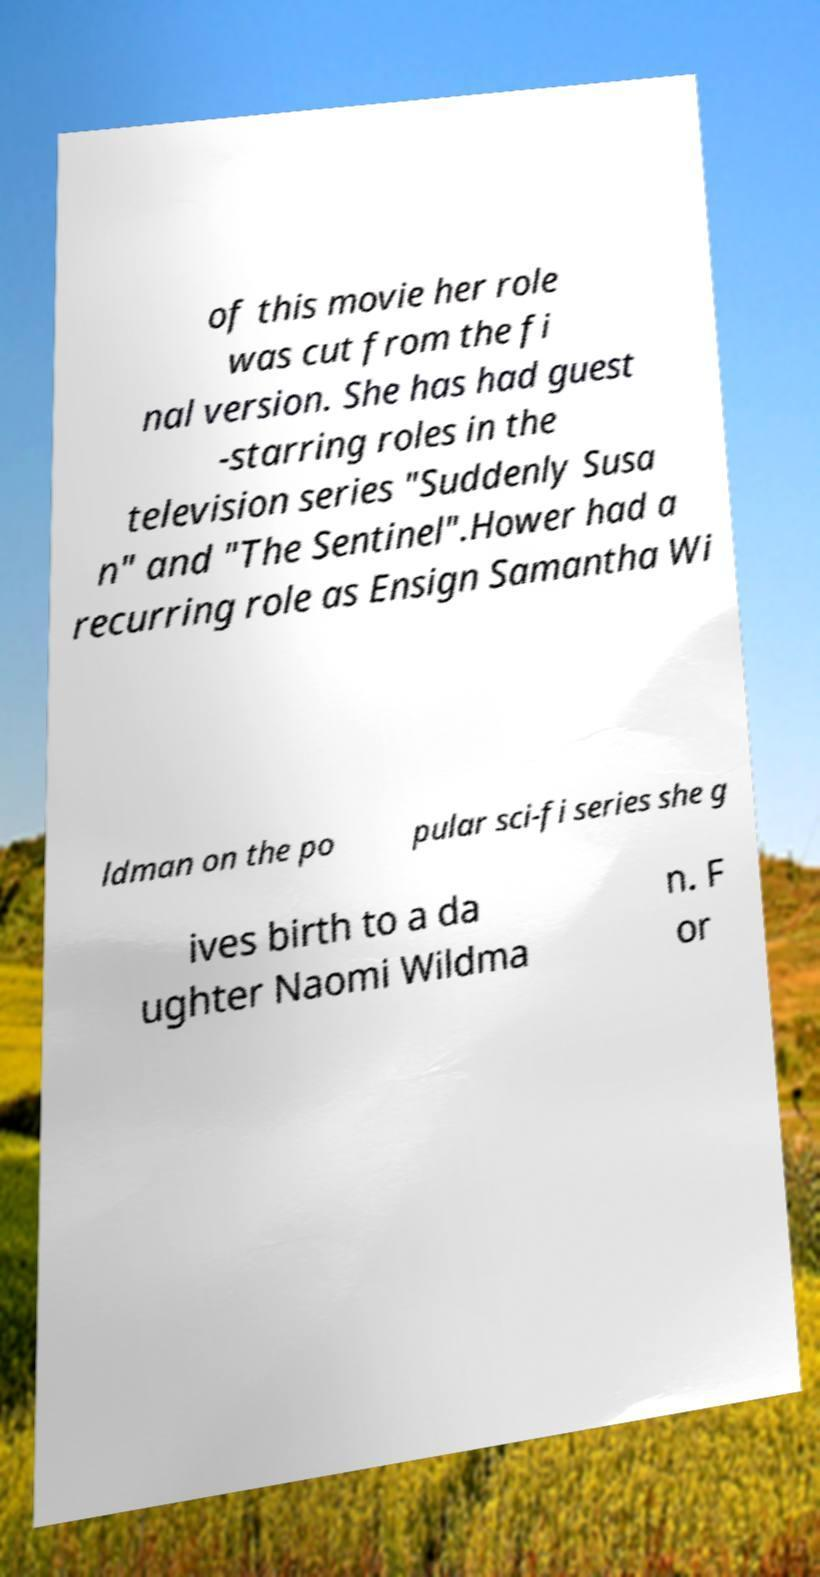Can you accurately transcribe the text from the provided image for me? of this movie her role was cut from the fi nal version. She has had guest -starring roles in the television series "Suddenly Susa n" and "The Sentinel".Hower had a recurring role as Ensign Samantha Wi ldman on the po pular sci-fi series she g ives birth to a da ughter Naomi Wildma n. F or 